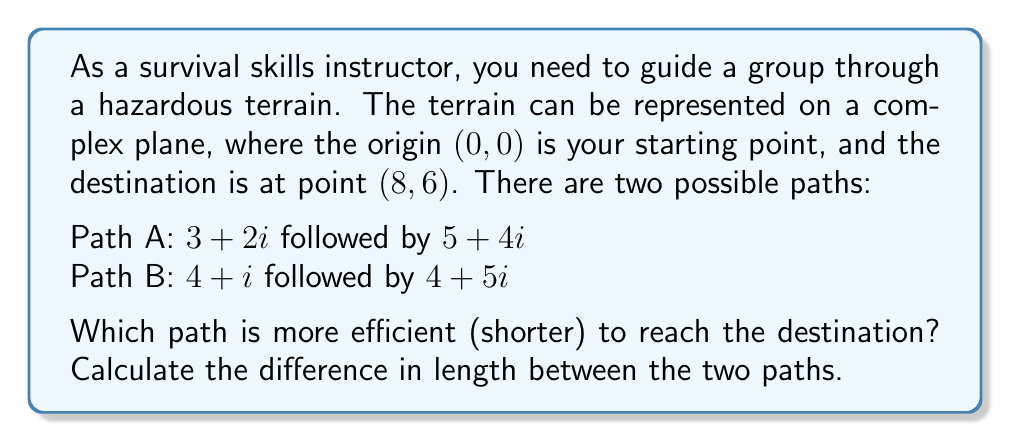Show me your answer to this math problem. To solve this problem, we'll use complex vectors and their properties:

1. First, let's verify that both paths lead to the destination (8,6):
   Path A: $(3+2i) + (5+4i) = 8+6i$
   Path B: $(4+i) + (4+5i) = 8+6i$

2. To find the length of each path, we need to calculate the magnitude of each vector and sum them:

   For Path A:
   Vector 1: $|3+2i| = \sqrt{3^2 + 2^2} = \sqrt{13}$
   Vector 2: $|5+4i| = \sqrt{5^2 + 4^2} = \sqrt{41}$
   Total length of Path A: $\sqrt{13} + \sqrt{41}$

   For Path B:
   Vector 1: $|4+i| = \sqrt{4^2 + 1^2} = \sqrt{17}$
   Vector 2: $|4+5i| = \sqrt{4^2 + 5^2} = \sqrt{41}$
   Total length of Path B: $\sqrt{17} + \sqrt{41}$

3. To find the difference in length:
   Difference = Length of Path A - Length of Path B
               = $(\sqrt{13} + \sqrt{41}) - (\sqrt{17} + \sqrt{41})$
               = $\sqrt{13} - \sqrt{17}$

4. To determine which path is shorter:
   If the difference is positive, Path B is shorter.
   If the difference is negative, Path A is shorter.

   $\sqrt{13} \approx 3.6056$ and $\sqrt{17} \approx 4.1231$
   
   Therefore, $\sqrt{13} - \sqrt{17}$ is negative, indicating that Path A is shorter.
Answer: Path A is more efficient (shorter). The difference in length between the two paths is $\sqrt{13} - \sqrt{17}$ units, which is approximately -0.5175 units. 